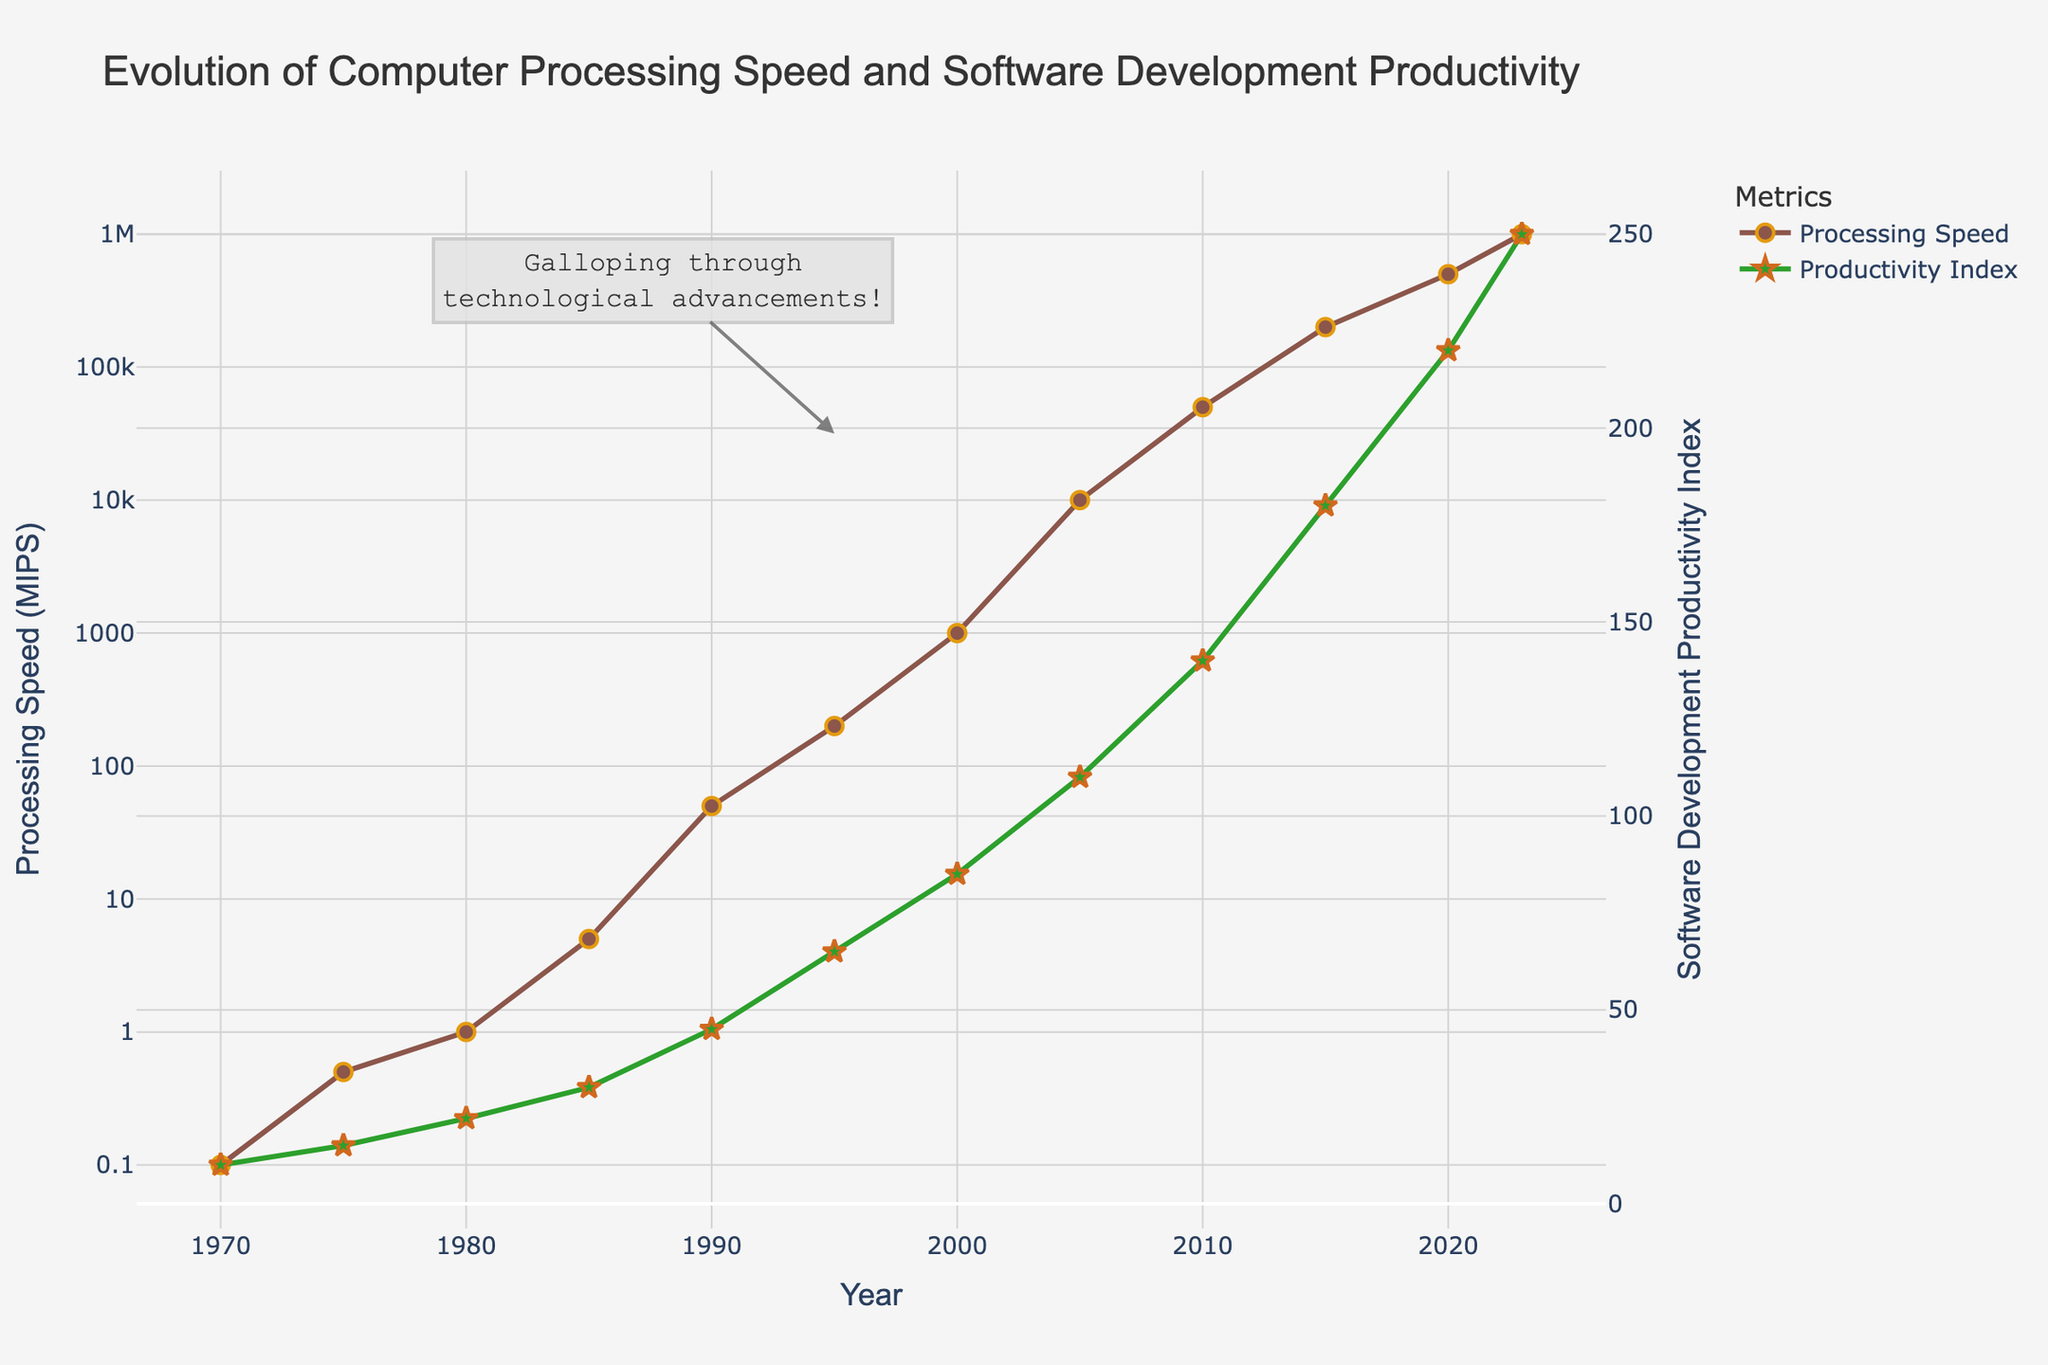What's the difference in Processing Speed (MIPS) between 1990 and 2000? Look at the Processing Speed values for 1990 and 2000. Subtract the value of 1990 from the value of 2000 to get the difference: 1000 - 50 = 950 MIPS.
Answer: 950 MIPS Which year shows the greatest increase in Software Development Productivity Index? Identify the differences in the Software Development Productivity Index from one year to the next and find the highest value. The greatest increase happens from 2005 to 2010, which is 140 - 110 = 30.
Answer: 2010 Which metric uses a logarithmic scale on the y-axis? The y-axes properties show that Processing Speed (MIPS) is using a logarithmic scale.
Answer: Processing Speed (MIPS) What color is used to represent the Software Development Productivity Index line in the figure? The description of the traces shows Software Development Productivity Index is represented by a green line.
Answer: Green How did the Processing Speed (MIPS) change from 1985 to 1990? Check the Processing Speed values for 1985 and 1990. There is a significant increase from 5 MIPS to 50 MIPS. The change is 50 - 5 = 45 MIPS.
Answer: 45 MIPS When did the Processing Speed (MIPS) first exceed 1000 MIPS? Look at the Processing Speed over years and identify when it first exceeds 1000 MIPS. This happened in the year 2000.
Answer: 2000 Was the increase in the Software Development Productivity Index from 1975 to 1985 greater than or less than the increase from 2000 to 2010? Calculate the increases for both periods: 1985-1975: 30 - 15 = 15; 2010-2000: 140 - 85 = 55. The increase from 2000 to 2010 is greater.
Answer: Greater In which year does the annotation "Galloping through technological advancements!" appear? The annotation is shown near the year 1995.
Answer: 1995 How many years did it take for the Processing Speed (MIPS) to grow from 0.1 to 1000? Processing Speed (MIPS) was 0.1 in 1970 and 1000 in 2000. Subtract 1970 from 2000 to find the years: 2000 - 1970 = 30 years.
Answer: 30 years 